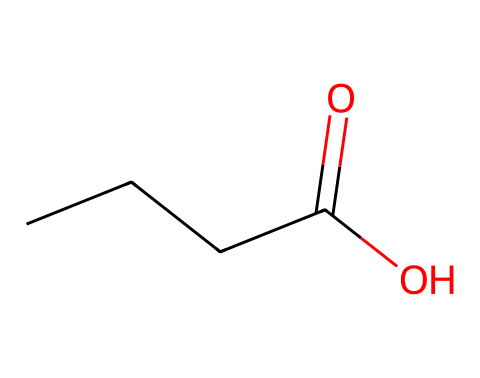What is the total number of carbon atoms in butyric acid? The SMILES representation "CCCC(=O)O" indicates four carbon atoms, as each "C" in the structure represents a carbon atom.
Answer: four How many oxygen atoms are present in butyric acid? In the SMILES "CCCC(=O)O", there are two "O" atoms indicated; one in the carboxylic functional group and another as a part of the carbonyl group.
Answer: two What type of functional group is found in butyric acid? The SMILES shows "C(=O)O" indicating a carboxylic acid functional group, characterized by a carbon atom double-bonded to an oxygen atom and single-bonded to a hydroxyl (–OH) group.
Answer: carboxylic acid How many hydrogen atoms are connected to the last carbon in butyric acid? The last carbon in the chain (the terminal carbon of "CCCC") has two hydrogen atoms attached to it, as indicated by the structure where the carbon makes four total bonds (three are with other carbons and one with hydrogen).
Answer: two Is butyric acid a saturated or unsaturated compound? The absence of any double bonds in the carbon chain (aside from the carbonyl) indicates that all the carbon atoms are fully bonded with hydrogen, making butyric acid a saturated compound.
Answer: saturated What is the main reason for the characteristic smell of butyric acid in cheese? Butyric acid contributes to the characteristic cheese aroma due to the presence of the carboxylic acid group, which often has a pungent odor, particularly in aged cheeses.
Answer: pungent odor 